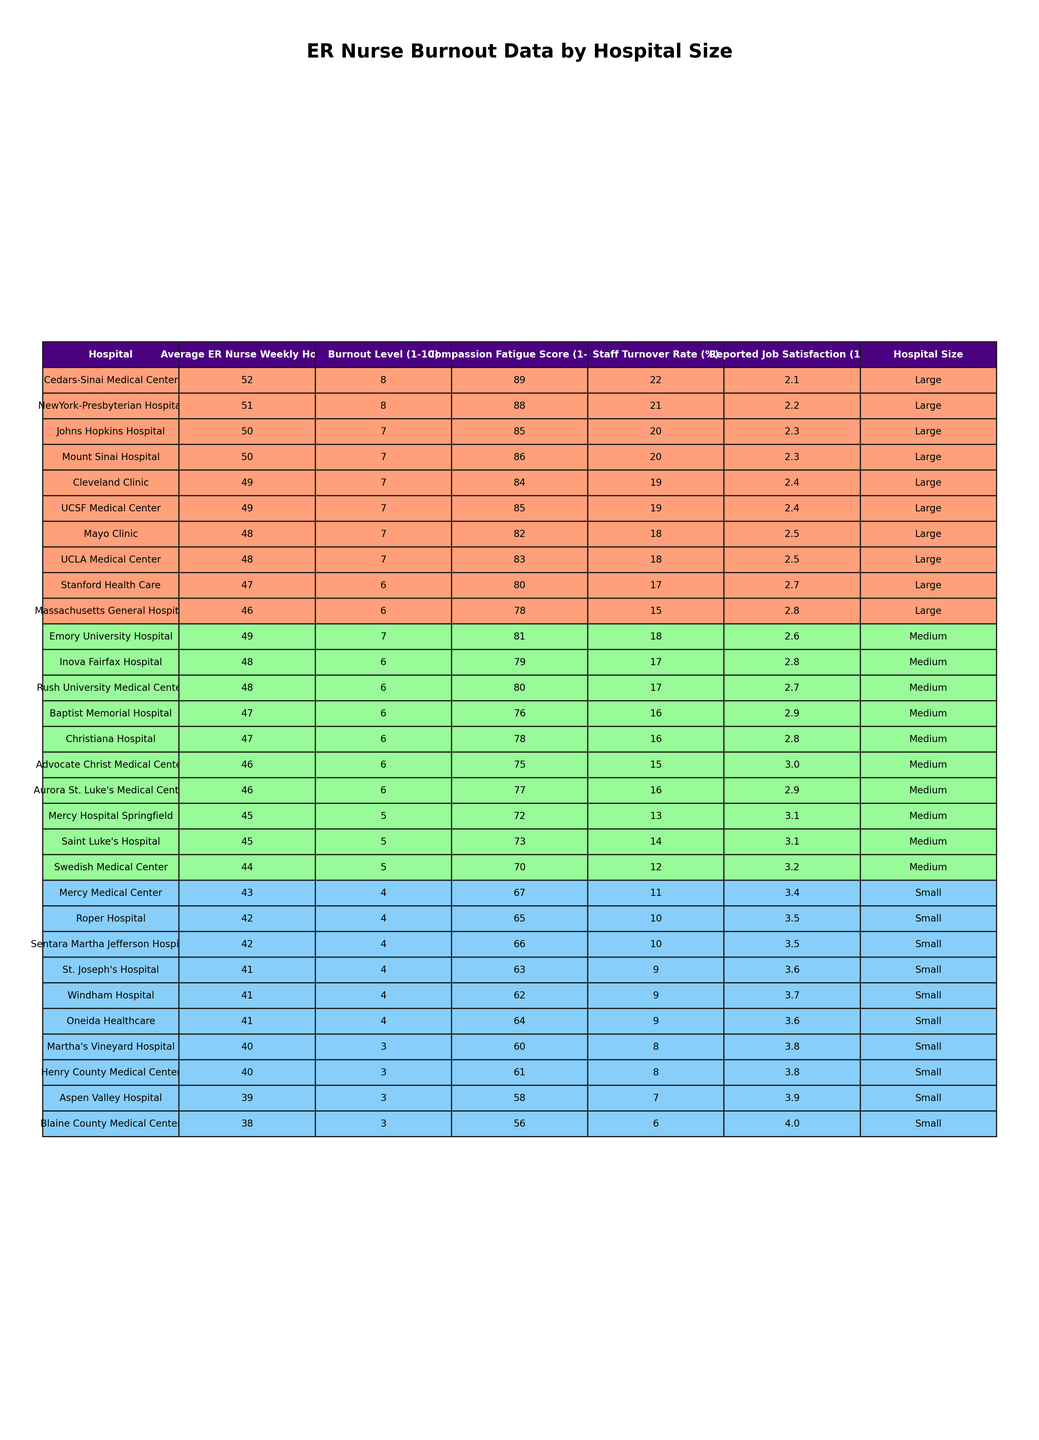What is the burnout level of the nurse at the Mayo Clinic? The table shows that the burnout level for the Mayo Clinic is listed as 7.
Answer: 7 Which hospital has the highest compassion fatigue score? By examining the compassion fatigue scores in the table, Cedars-Sinai Medical Center has the highest score of 89.
Answer: 89 What is the average weekly work hours for small-sized hospitals? The average of the average weekly work hours (42, 43, 41, 40, 41, 39, 42, 38, 40, 41) equals (42 + 43 + 41 + 40 + 41 + 39 + 42 + 38 + 40 + 41) / 10 = 41.
Answer: 41 Is the reported job satisfaction higher in medium-sized hospitals or small-sized hospitals? Comparing the reported job satisfaction scores, medium-sized hospitals have scores of (3.1, 2.9, 3.0, 3.2, 3.1, 2.8, 2.9, 2.6, 2.7) which average to 2.87, while small-sized hospitals have (3.5, 3.4, 3.6, 3.8, 3.7, 3.9, 3.5, 4.0, 3.8, 3.6) which average to 3.66. Therefore, small-sized hospitals have higher job satisfaction.
Answer: Yes What is the staff turnover rate of the hospital with the lowest average nurse work hours? The hospital with the lowest average nurse work hours is Aspen Valley Hospital with 39 hours, which has a staff turnover rate of 7%.
Answer: 7 How does the burnout level of nurses in large hospitals compare to those in small hospitals? The average burnout level for large hospitals is calculated from their scores (7, 8, 7, 6, 7, 8, 6, 7, 7, 7) which totals 69, so the average is 69/10 = 6.9. For small hospitals, the scores (4, 4, 4, 3, 4, 3, 4, 3, 3, 4) total 36, averaging to 3.6. Large hospitals report a higher average burnout level compared to small hospitals.
Answer: Higher in large hospitals Which hospital has the lowest burnout level, and what is that level? The hospital with the lowest burnout level is Martha's Vineyard Hospital, which has a level of 3.
Answer: 3 What is the difference in average weekly work hours between large hospitals and small hospitals? The average weekly work hours for large hospitals, based on their values (48, 52, 50, 46, 49, 51, 47, 50, 48, 49), is 49. For small hospitals with (42, 43, 41, 40, 41, 39, 42, 38, 40, 41), it is 41. Thus, the difference is 49 - 41 = 8.
Answer: 8 Is there any small hospital with a burnout level higher than 5? By examining the burnout levels of small hospitals, all of them (4, 4, 4, 3, 4, 3, 4, 3, 3, 4) are 5 or lower. Thus, there are no small hospitals with higher burnout levels than 5.
Answer: No Which medium-sized hospital has the highest reported job satisfaction? In medium-sized hospitals, the reported job satisfaction scores are (3.1, 2.9, 3.0, 3.2, 3.1, 2.8, 2.9, 2.6, 2.7). The highest score, 3.1, corresponds to Mercy Hospital Springfield and Saint Luke's Hospital.
Answer: 3.1 What is the burnout level for the hospital with the highest staff turnover rate? The highest staff turnover rate is 22%, which corresponds to Cedars-Sinai Medical Center. Its burnout level is 8.
Answer: 8 